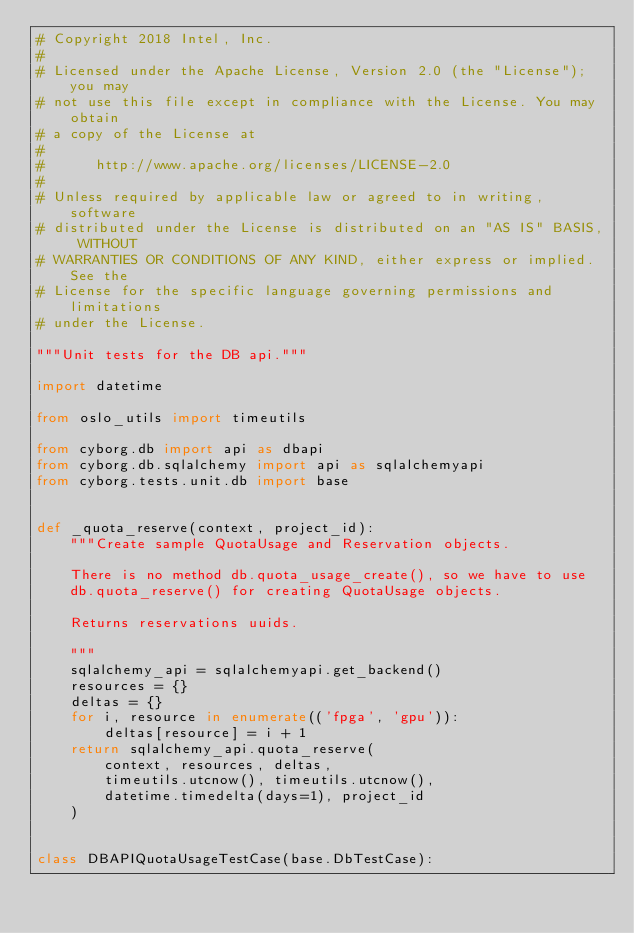<code> <loc_0><loc_0><loc_500><loc_500><_Python_># Copyright 2018 Intel, Inc.
#
# Licensed under the Apache License, Version 2.0 (the "License"); you may
# not use this file except in compliance with the License. You may obtain
# a copy of the License at
#
#      http://www.apache.org/licenses/LICENSE-2.0
#
# Unless required by applicable law or agreed to in writing, software
# distributed under the License is distributed on an "AS IS" BASIS, WITHOUT
# WARRANTIES OR CONDITIONS OF ANY KIND, either express or implied. See the
# License for the specific language governing permissions and limitations
# under the License.

"""Unit tests for the DB api."""

import datetime

from oslo_utils import timeutils

from cyborg.db import api as dbapi
from cyborg.db.sqlalchemy import api as sqlalchemyapi
from cyborg.tests.unit.db import base


def _quota_reserve(context, project_id):
    """Create sample QuotaUsage and Reservation objects.

    There is no method db.quota_usage_create(), so we have to use
    db.quota_reserve() for creating QuotaUsage objects.

    Returns reservations uuids.

    """
    sqlalchemy_api = sqlalchemyapi.get_backend()
    resources = {}
    deltas = {}
    for i, resource in enumerate(('fpga', 'gpu')):
        deltas[resource] = i + 1
    return sqlalchemy_api.quota_reserve(
        context, resources, deltas,
        timeutils.utcnow(), timeutils.utcnow(),
        datetime.timedelta(days=1), project_id
    )


class DBAPIQuotaUsageTestCase(base.DbTestCase):
</code> 